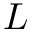Convert formula to latex. <formula><loc_0><loc_0><loc_500><loc_500>L</formula> 